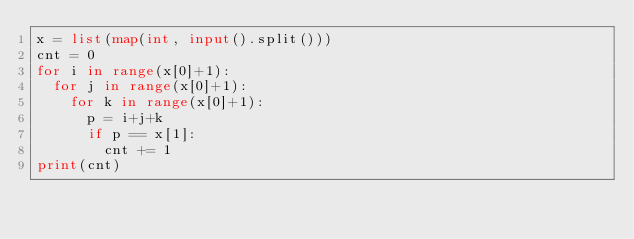Convert code to text. <code><loc_0><loc_0><loc_500><loc_500><_Python_>x = list(map(int, input().split()))
cnt = 0
for i in range(x[0]+1):
  for j in range(x[0]+1):
    for k in range(x[0]+1):
      p = i+j+k
      if p == x[1]:
        cnt += 1
print(cnt)
</code> 